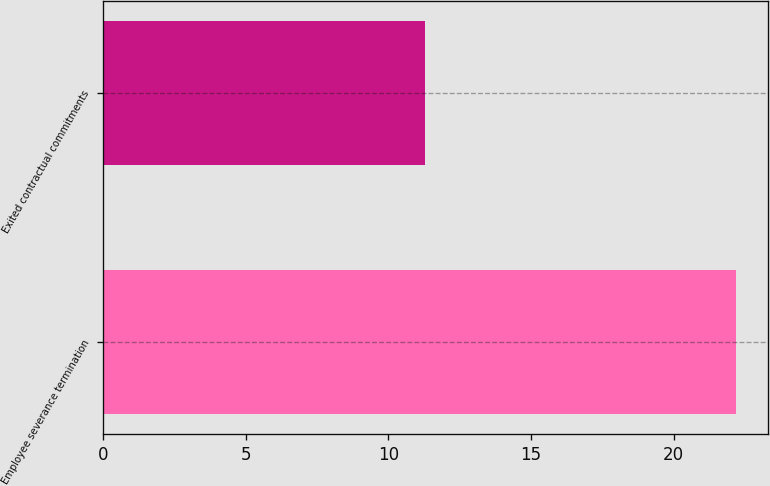Convert chart. <chart><loc_0><loc_0><loc_500><loc_500><bar_chart><fcel>Employee severance termination<fcel>Exited contractual commitments<nl><fcel>22.2<fcel>11.3<nl></chart> 